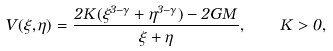<formula> <loc_0><loc_0><loc_500><loc_500>V ( \xi , \eta ) = \frac { 2 K ( \xi ^ { 3 - \gamma } + \eta ^ { 3 - \gamma } ) - 2 G M } { \xi + \eta } , \quad K > 0 ,</formula> 